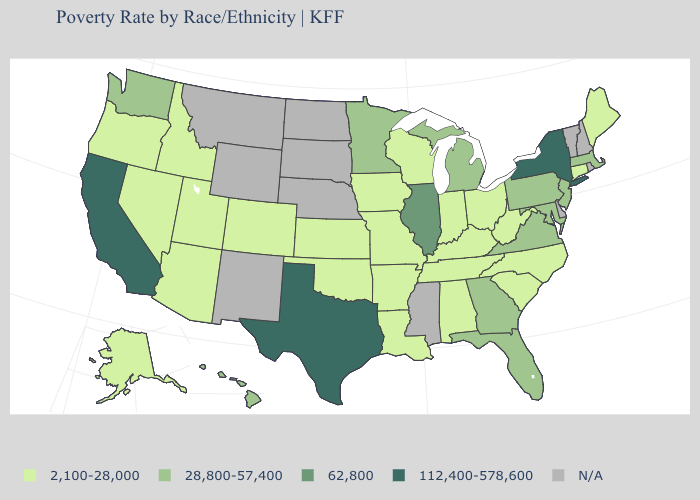Does Illinois have the highest value in the MidWest?
Answer briefly. Yes. Name the states that have a value in the range 28,800-57,400?
Quick response, please. Florida, Georgia, Hawaii, Maryland, Massachusetts, Michigan, Minnesota, New Jersey, Pennsylvania, Virginia, Washington. Which states have the highest value in the USA?
Be succinct. California, New York, Texas. Does the map have missing data?
Be succinct. Yes. Name the states that have a value in the range 2,100-28,000?
Short answer required. Alabama, Alaska, Arizona, Arkansas, Colorado, Connecticut, Idaho, Indiana, Iowa, Kansas, Kentucky, Louisiana, Maine, Missouri, Nevada, North Carolina, Ohio, Oklahoma, Oregon, South Carolina, Tennessee, Utah, West Virginia, Wisconsin. Which states hav the highest value in the West?
Quick response, please. California. What is the value of Michigan?
Answer briefly. 28,800-57,400. Name the states that have a value in the range N/A?
Quick response, please. Delaware, Mississippi, Montana, Nebraska, New Hampshire, New Mexico, North Dakota, Rhode Island, South Dakota, Vermont, Wyoming. Name the states that have a value in the range N/A?
Give a very brief answer. Delaware, Mississippi, Montana, Nebraska, New Hampshire, New Mexico, North Dakota, Rhode Island, South Dakota, Vermont, Wyoming. What is the value of California?
Concise answer only. 112,400-578,600. Among the states that border South Carolina , does Georgia have the highest value?
Answer briefly. Yes. How many symbols are there in the legend?
Keep it brief. 5. Does Connecticut have the lowest value in the USA?
Answer briefly. Yes. What is the value of Montana?
Keep it brief. N/A. What is the value of Connecticut?
Short answer required. 2,100-28,000. 